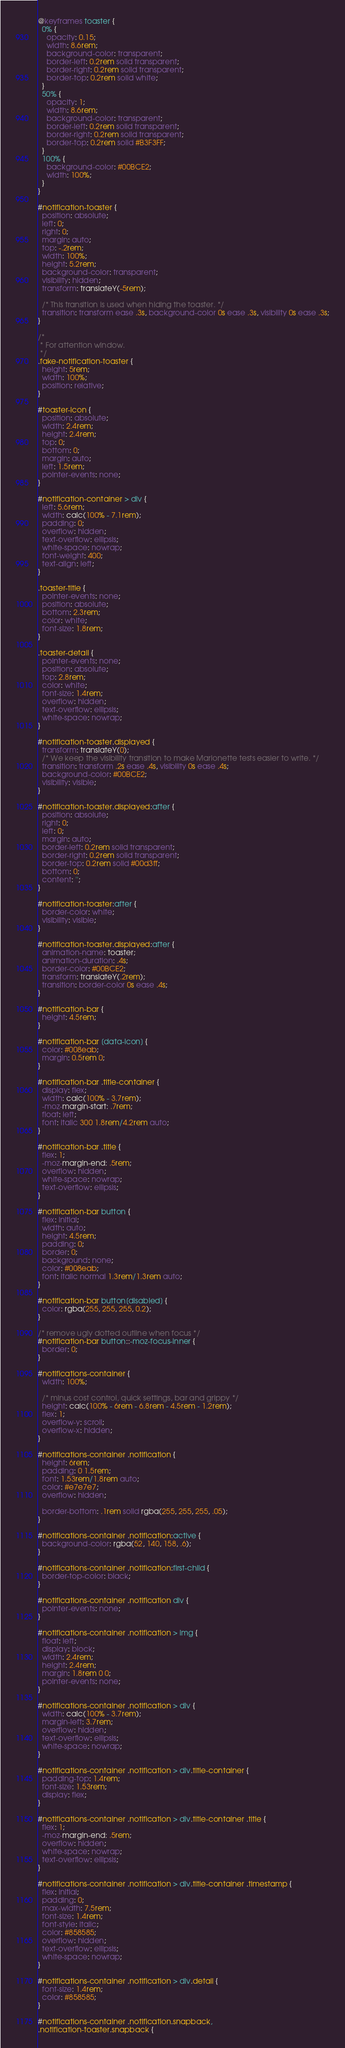Convert code to text. <code><loc_0><loc_0><loc_500><loc_500><_CSS_>@keyframes toaster {
  0% {
    opacity: 0.15;
    width: 8.6rem;
    background-color: transparent;
    border-left: 0.2rem solid transparent;
    border-right: 0.2rem solid transparent;
    border-top: 0.2rem solid white;
  }
  50% {
    opacity: 1;
    width: 8.6rem;
    background-color: transparent;
    border-left: 0.2rem solid transparent;
    border-right: 0.2rem solid transparent;
    border-top: 0.2rem solid #B3F3FF;
  }
  100% {
    background-color: #00BCE2;
    width: 100%;
  }
}

#notification-toaster {
  position: absolute;
  left: 0;
  right: 0;
  margin: auto;
  top: -.2rem;
  width: 100%;
  height: 5.2rem;
  background-color: transparent;
  visibility: hidden;
  transform: translateY(-5rem);

  /* This transition is used when hiding the toaster. */
  transition: transform ease .3s, background-color 0s ease .3s, visibility 0s ease .3s;
}

/*
 * For attention window.
 */
.fake-notification-toaster {
  height: 5rem;
  width: 100%;
  position: relative;
}

#toaster-icon {
  position: absolute;
  width: 2.4rem;
  height: 2.4rem;
  top: 0;
  bottom: 0;
  margin: auto;
  left: 1.5rem;
  pointer-events: none;
}

#notification-container > div {
  left: 5.6rem;
  width: calc(100% - 7.1rem);
  padding: 0;
  overflow: hidden;
  text-overflow: ellipsis;
  white-space: nowrap;
  font-weight: 400;
  text-align: left;
}

.toaster-title {
  pointer-events: none;
  position: absolute;
  bottom: 2.3rem;
  color: white;
  font-size: 1.8rem;
}

.toaster-detail {
  pointer-events: none;
  position: absolute;
  top: 2.8rem;
  color: white;
  font-size: 1.4rem;
  overflow: hidden;
  text-overflow: ellipsis;
  white-space: nowrap;
}

#notification-toaster.displayed {
  transform: translateY(0);
  /* We keep the visibility transition to make Marionette tests easier to write. */
  transition: transform .2s ease .4s, visibility 0s ease .4s;
  background-color: #00BCE2;
  visibility: visible;
}

#notification-toaster.displayed:after {
  position: absolute;
  right: 0;
  left: 0;
  margin: auto;
  border-left: 0.2rem solid transparent;
  border-right: 0.2rem solid transparent;
  border-top: 0.2rem solid #00d3ff;
  bottom: 0;
  content: '';
}

#notification-toaster:after {
  border-color: white;
  visibility: visible;
}

#notification-toaster.displayed:after {
  animation-name: toaster;
  animation-duration: .4s;
  border-color: #00BCE2;
  transform: translateY(.2rem);
  transition: border-color 0s ease .4s;
}

#notification-bar {
  height: 4.5rem;
}

#notification-bar [data-icon] {
  color: #008eab;
  margin: 0.5rem 0;
}

#notification-bar .title-container {
  display: flex;
  width: calc(100% - 3.7rem);
  -moz-margin-start: .7rem;
  float: left;
  font: italic 300 1.8rem/4.2rem auto;
}

#notification-bar .title {
  flex: 1;
  -moz-margin-end: .5rem;
  overflow: hidden;
  white-space: nowrap;
  text-overflow: ellipsis;
}

#notification-bar button {
  flex: initial;
  width: auto;
  height: 4.5rem;
  padding: 0;
  border: 0;
  background: none;
  color: #008eab;
  font: italic normal 1.3rem/1.3rem auto;
}

#notification-bar button[disabled] {
  color: rgba(255, 255, 255, 0.2);
}

/* remove ugly dotted outline when focus */
#notification-bar button::-moz-focus-inner {
  border: 0;
}

#notifications-container {
  width: 100%;

  /* minus cost control, quick settings, bar and grippy */
  height: calc(100% - 6rem - 6.8rem - 4.5rem - 1.2rem);
  flex: 1;
  overflow-y: scroll;
  overflow-x: hidden;
}

#notifications-container .notification {
  height: 6rem;
  padding: 0 1.5rem;
  font: 1.53rem/1.8rem auto;
  color: #e7e7e7;
  overflow: hidden;

  border-bottom: .1rem solid rgba(255, 255, 255, .05);
}

#notifications-container .notification:active {
  background-color: rgba(52, 140, 158, .6);
}

#notifications-container .notification:first-child {
  border-top-color: black;
}

#notifications-container .notification div {
  pointer-events: none;
}

#notifications-container .notification > img {
  float: left;
  display: block;
  width: 2.4rem;
  height: 2.4rem;
  margin: 1.8rem 0 0;
  pointer-events: none;
}

#notifications-container .notification > div {
  width: calc(100% - 3.7rem);
  margin-left: 3.7rem;
  overflow: hidden;
  text-overflow: ellipsis;
  white-space: nowrap;
}

#notifications-container .notification > div.title-container {
  padding-top: 1.4rem;
  font-size: 1.53rem;
  display: flex;
}

#notifications-container .notification > div.title-container .title {
  flex: 1;
  -moz-margin-end: .5rem;
  overflow: hidden;
  white-space: nowrap;
  text-overflow: ellipsis;
}

#notifications-container .notification > div.title-container .timestamp {
  flex: initial;
  padding: 0;
  max-width: 7.5rem;
  font-size: 1.4rem;
  font-style: italic;
  color: #858585;
  overflow: hidden;
  text-overflow: ellipsis;
  white-space: nowrap;
}

#notifications-container .notification > div.detail {
  font-size: 1.4rem;
  color: #858585;
}

#notifications-container .notification.snapback,
.notification-toaster.snapback {</code> 